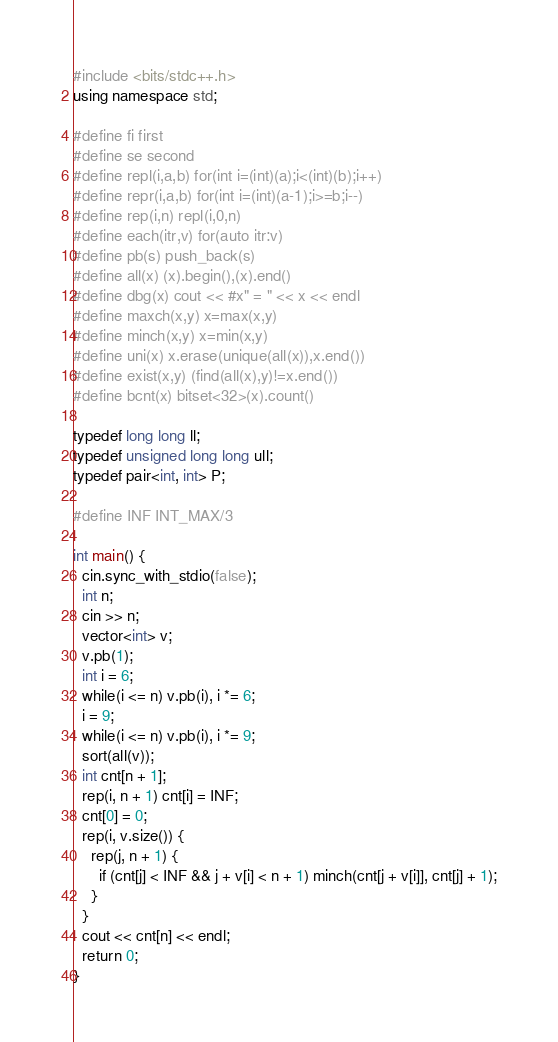<code> <loc_0><loc_0><loc_500><loc_500><_C++_>#include <bits/stdc++.h>
using namespace std;

#define fi first
#define se second
#define repl(i,a,b) for(int i=(int)(a);i<(int)(b);i++)
#define repr(i,a,b) for(int i=(int)(a-1);i>=b;i--)
#define rep(i,n) repl(i,0,n)
#define each(itr,v) for(auto itr:v)
#define pb(s) push_back(s)
#define all(x) (x).begin(),(x).end()
#define dbg(x) cout << #x" = " << x << endl
#define maxch(x,y) x=max(x,y)
#define minch(x,y) x=min(x,y)
#define uni(x) x.erase(unique(all(x)),x.end())
#define exist(x,y) (find(all(x),y)!=x.end())
#define bcnt(x) bitset<32>(x).count()

typedef long long ll;
typedef unsigned long long ull;
typedef pair<int, int> P;

#define INF INT_MAX/3

int main() {
  cin.sync_with_stdio(false);
  int n;
  cin >> n;
  vector<int> v;
  v.pb(1);
  int i = 6;
  while(i <= n) v.pb(i), i *= 6;
  i = 9;
  while(i <= n) v.pb(i), i *= 9;
  sort(all(v));
  int cnt[n + 1];
  rep(i, n + 1) cnt[i] = INF;
  cnt[0] = 0;
  rep(i, v.size()) {
    rep(j, n + 1) {
      if (cnt[j] < INF && j + v[i] < n + 1) minch(cnt[j + v[i]], cnt[j] + 1);
    }
  }
  cout << cnt[n] << endl;
  return 0;
}
</code> 